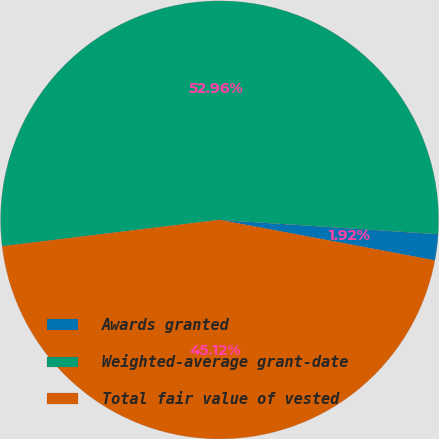<chart> <loc_0><loc_0><loc_500><loc_500><pie_chart><fcel>Awards granted<fcel>Weighted-average grant-date<fcel>Total fair value of vested<nl><fcel>1.92%<fcel>52.96%<fcel>45.12%<nl></chart> 